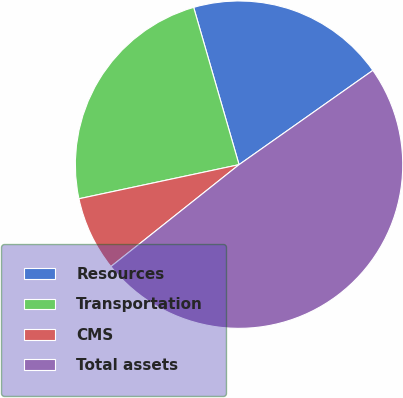Convert chart to OTSL. <chart><loc_0><loc_0><loc_500><loc_500><pie_chart><fcel>Resources<fcel>Transportation<fcel>CMS<fcel>Total assets<nl><fcel>19.7%<fcel>23.87%<fcel>7.35%<fcel>49.08%<nl></chart> 